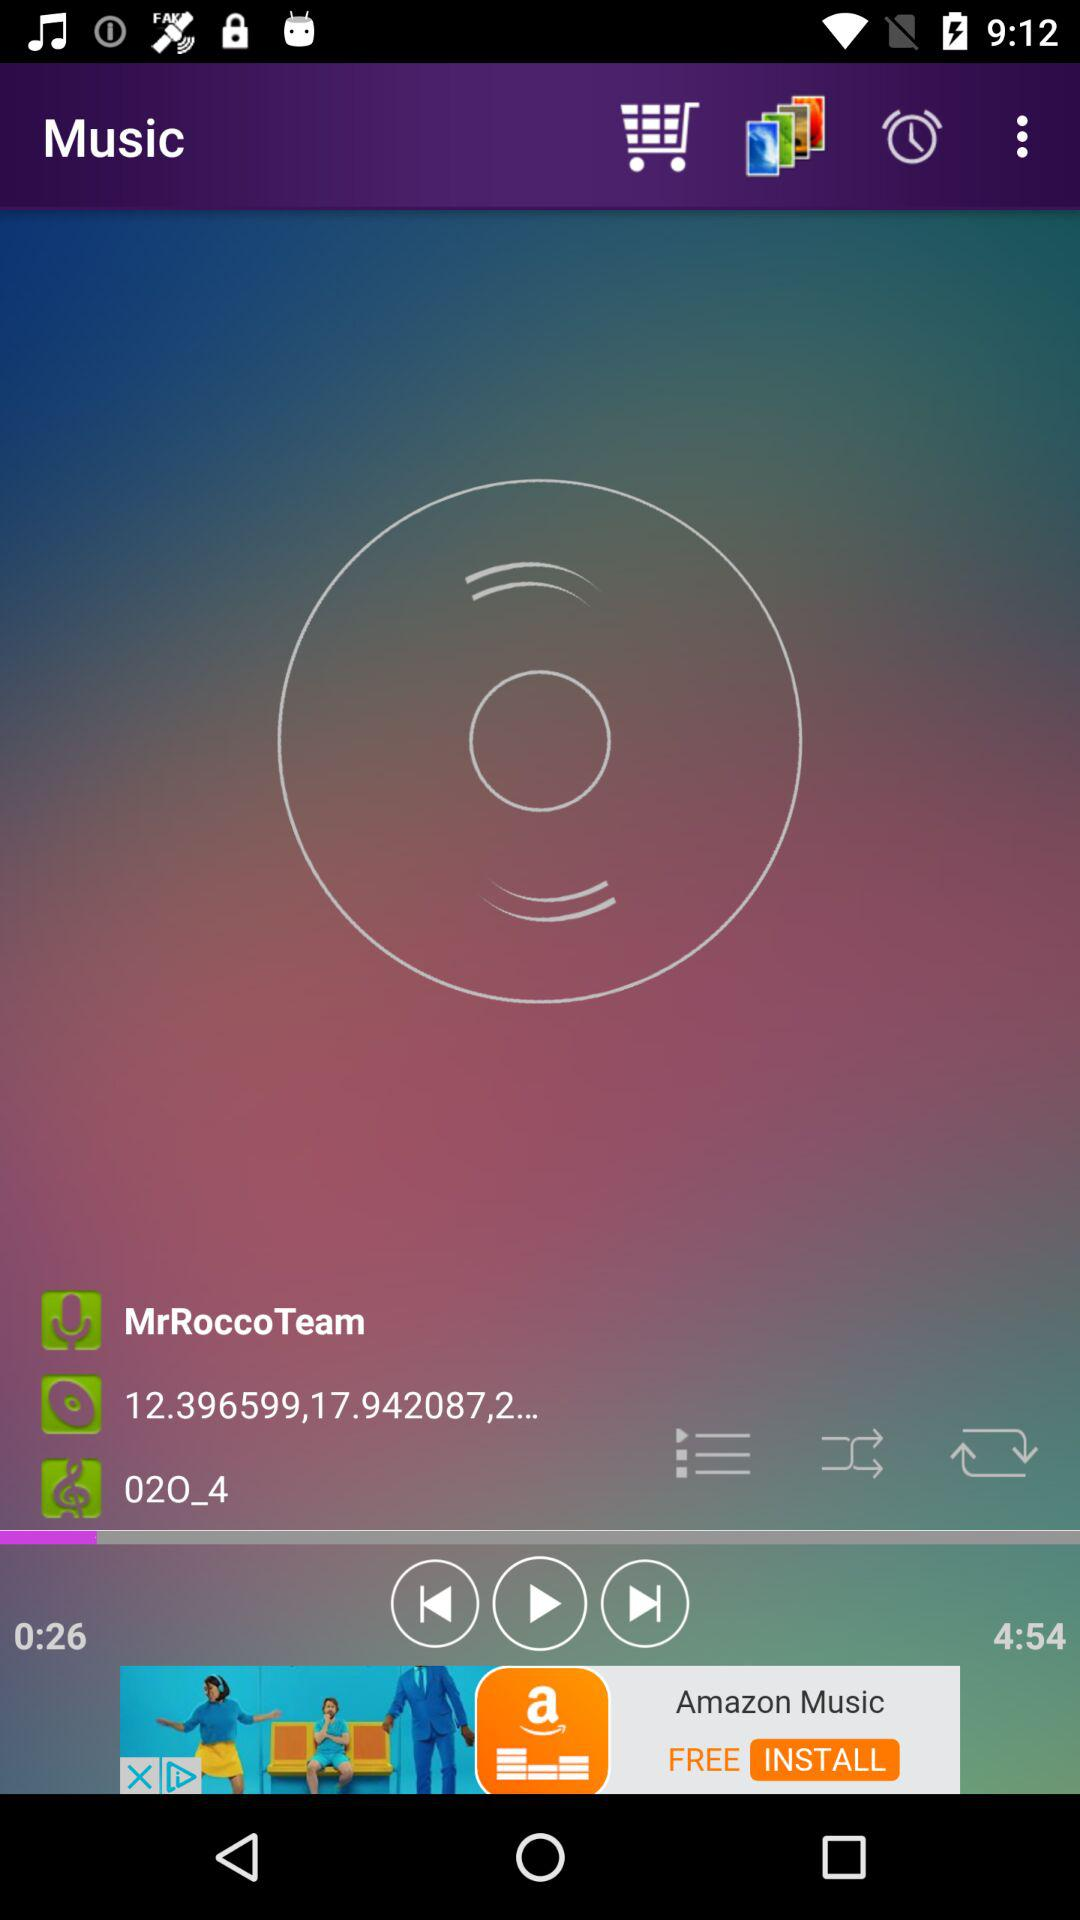What is the application name? The application name is "Music". 